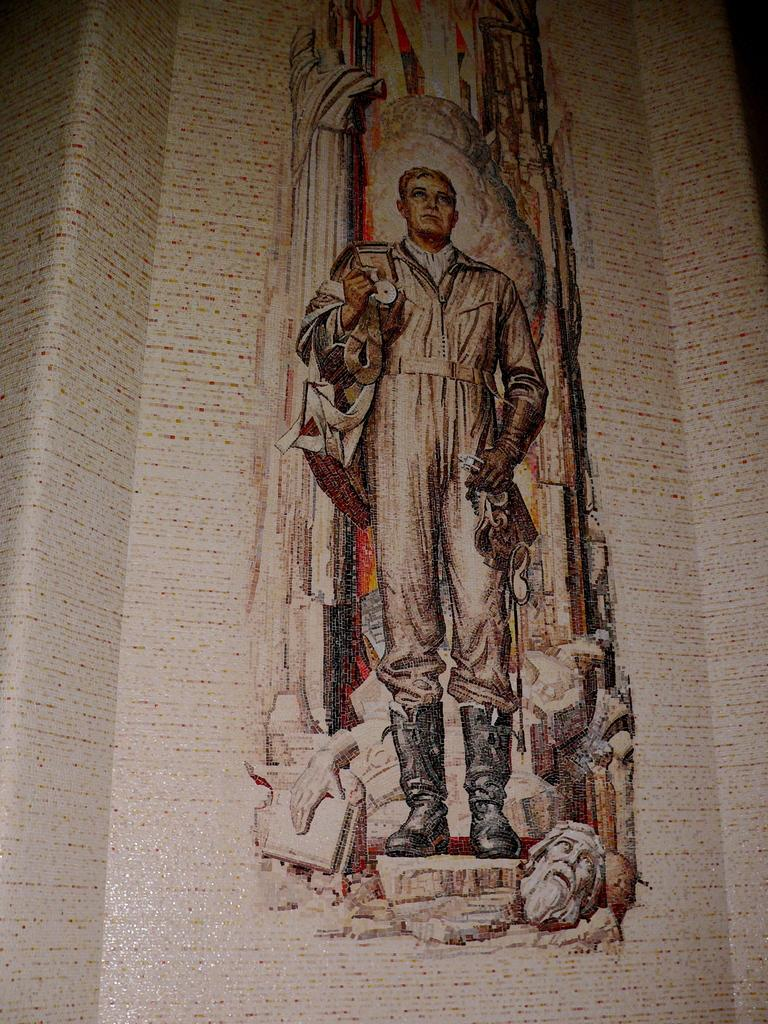What type of artwork is shown in the image? The image is a painting. Where is the painting located? The painting is on a wall. What is the main subject of the painting? There is a person depicted in the painting. What parts of the person's body are visible in the painting? The person's hand and face are visible in the painting. Can you see any grass growing in the painting? There is no grass visible in the painting; it is a painting of a person. Is the person depicted in the painting blowing on something? There is no indication in the painting that the person is blowing on anything. 